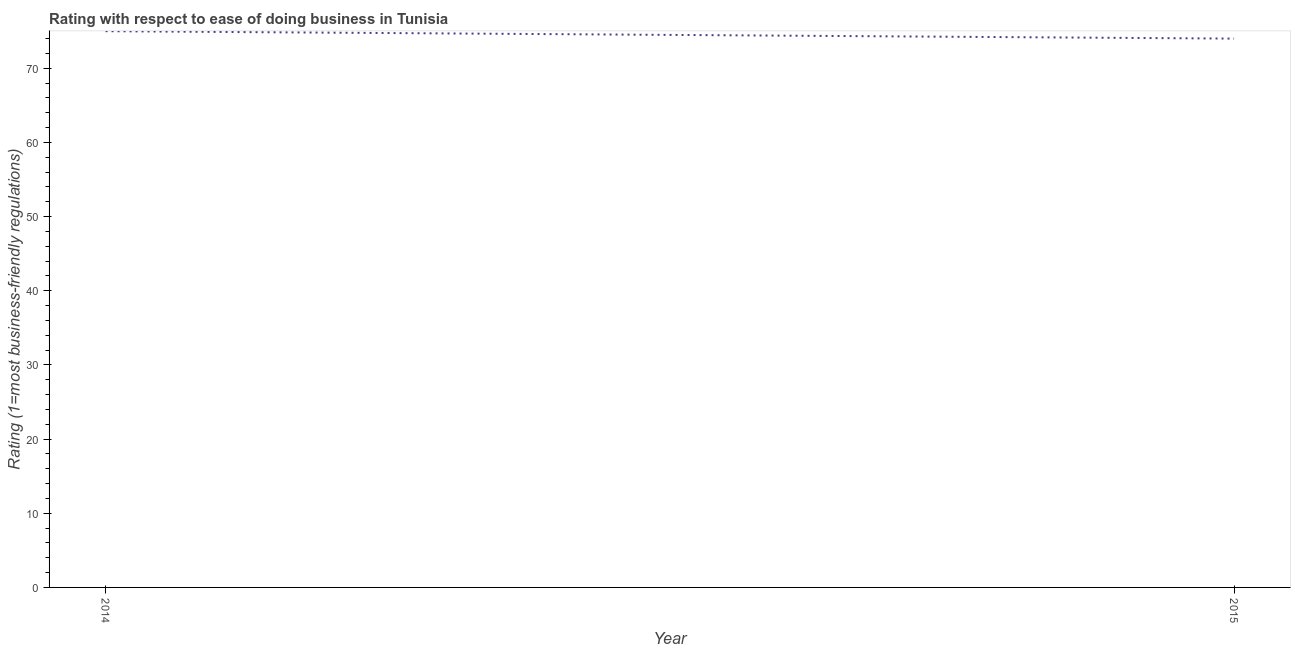What is the ease of doing business index in 2014?
Ensure brevity in your answer.  75. Across all years, what is the maximum ease of doing business index?
Your response must be concise. 75. Across all years, what is the minimum ease of doing business index?
Provide a succinct answer. 74. In which year was the ease of doing business index minimum?
Provide a short and direct response. 2015. What is the sum of the ease of doing business index?
Provide a succinct answer. 149. What is the difference between the ease of doing business index in 2014 and 2015?
Offer a very short reply. 1. What is the average ease of doing business index per year?
Make the answer very short. 74.5. What is the median ease of doing business index?
Give a very brief answer. 74.5. Do a majority of the years between 2015 and 2014 (inclusive) have ease of doing business index greater than 28 ?
Provide a short and direct response. No. What is the ratio of the ease of doing business index in 2014 to that in 2015?
Give a very brief answer. 1.01. In how many years, is the ease of doing business index greater than the average ease of doing business index taken over all years?
Offer a terse response. 1. How many years are there in the graph?
Offer a terse response. 2. Are the values on the major ticks of Y-axis written in scientific E-notation?
Your response must be concise. No. What is the title of the graph?
Make the answer very short. Rating with respect to ease of doing business in Tunisia. What is the label or title of the X-axis?
Offer a very short reply. Year. What is the label or title of the Y-axis?
Offer a terse response. Rating (1=most business-friendly regulations). What is the Rating (1=most business-friendly regulations) in 2014?
Make the answer very short. 75. What is the Rating (1=most business-friendly regulations) in 2015?
Provide a succinct answer. 74. What is the difference between the Rating (1=most business-friendly regulations) in 2014 and 2015?
Provide a short and direct response. 1. What is the ratio of the Rating (1=most business-friendly regulations) in 2014 to that in 2015?
Your answer should be compact. 1.01. 